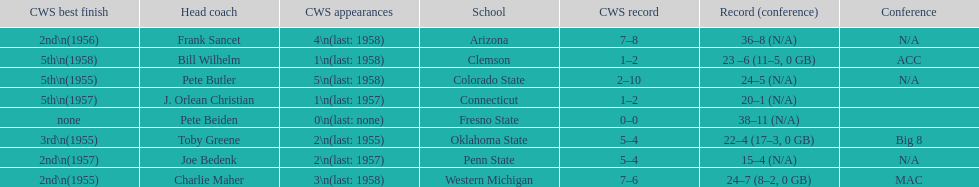Which was the only team with less than 20 wins? Penn State. 